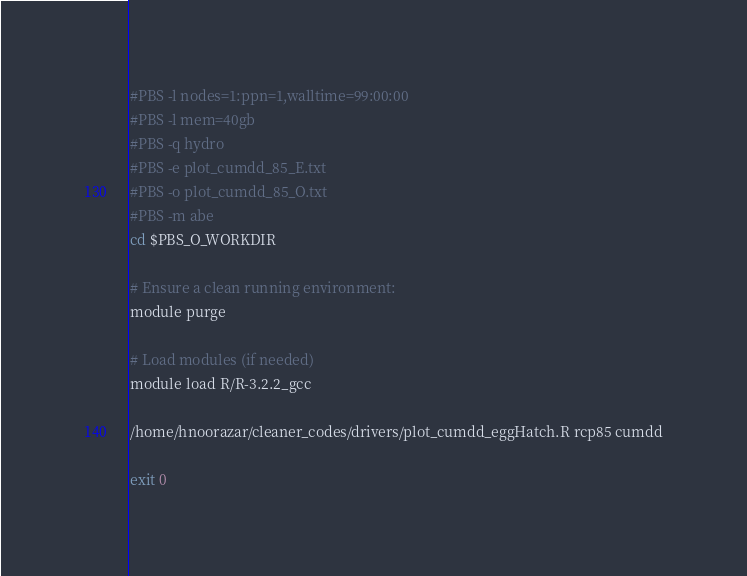Convert code to text. <code><loc_0><loc_0><loc_500><loc_500><_Bash_>#PBS -l nodes=1:ppn=1,walltime=99:00:00
#PBS -l mem=40gb
#PBS -q hydro
#PBS -e plot_cumdd_85_E.txt
#PBS -o plot_cumdd_85_O.txt
#PBS -m abe
cd $PBS_O_WORKDIR

# Ensure a clean running environment:
module purge

# Load modules (if needed)
module load R/R-3.2.2_gcc

/home/hnoorazar/cleaner_codes/drivers/plot_cumdd_eggHatch.R rcp85 cumdd

exit 0
</code> 